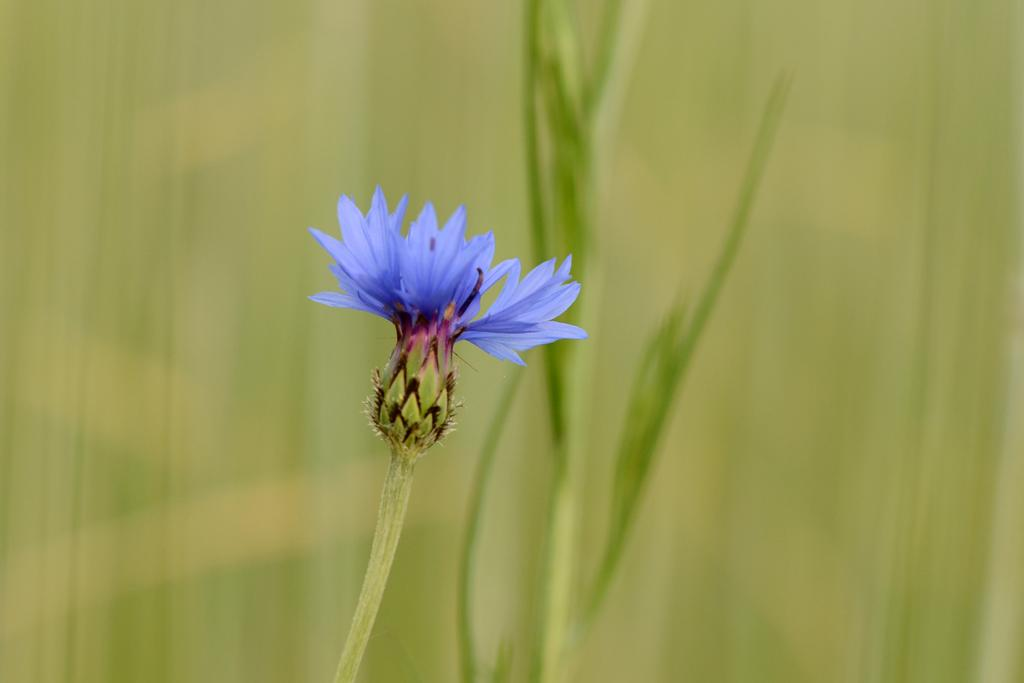What type of plant can be seen in the image? There is a flower in the image. Are there any other plants visible in the image? Yes, there are plants in the image. Can you describe the background of the image? The background of the image is blurry. What unit of measurement is used to determine the existence of fairies in the image? There is no mention of fairies or any unit of measurement in the image, so this question cannot be answered. 